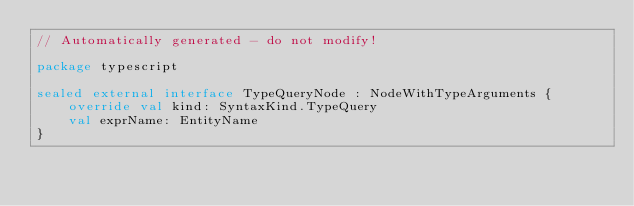<code> <loc_0><loc_0><loc_500><loc_500><_Kotlin_>// Automatically generated - do not modify!

package typescript

sealed external interface TypeQueryNode : NodeWithTypeArguments {
    override val kind: SyntaxKind.TypeQuery
    val exprName: EntityName
}
</code> 